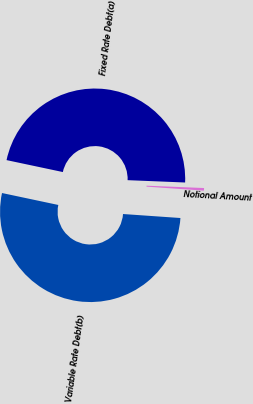<chart> <loc_0><loc_0><loc_500><loc_500><pie_chart><fcel>Fixed Rate Debt(a)<fcel>Variable Rate Debt(b)<fcel>Notional Amount<nl><fcel>47.32%<fcel>52.22%<fcel>0.46%<nl></chart> 